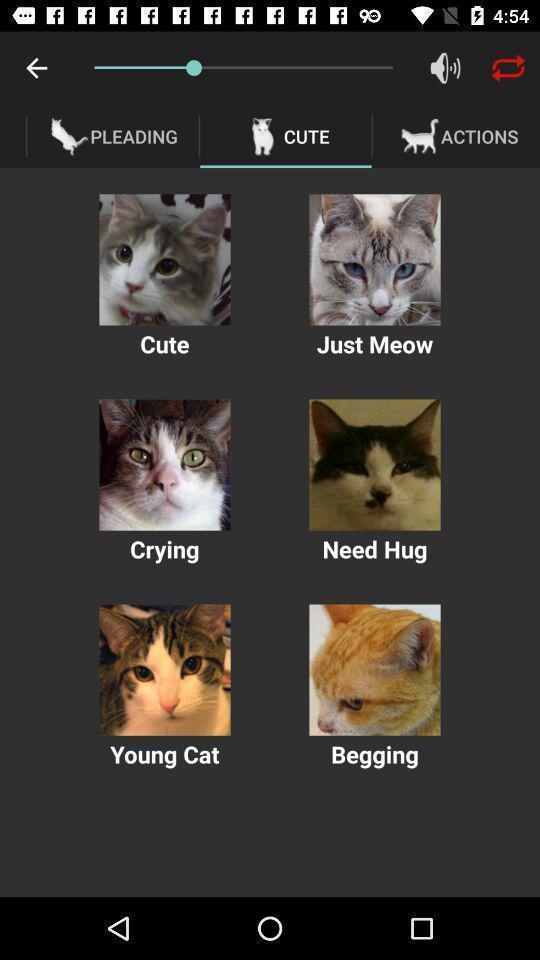Summarize the information in this screenshot. Various cat mimic audio displayed. 